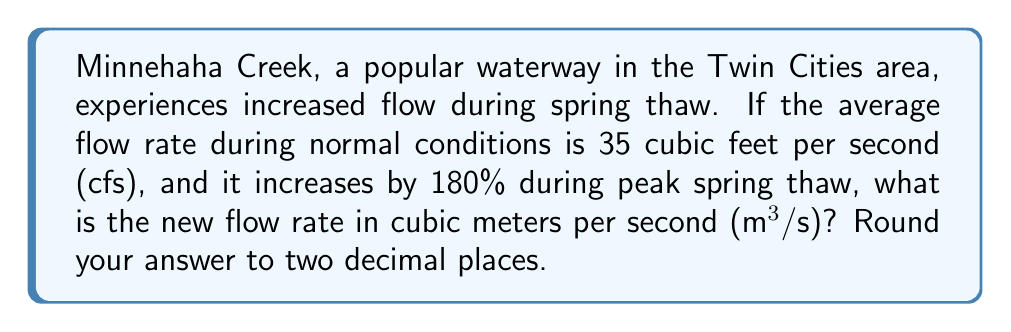Show me your answer to this math problem. Let's approach this problem step-by-step:

1. Identify the given information:
   - Normal flow rate: 35 cfs
   - Increase during spring thaw: 180%

2. Calculate the increase in flow rate:
   $$\text{Increase} = 35 \text{ cfs} \times 180\% = 35 \times 1.80 = 63 \text{ cfs}$$

3. Calculate the new flow rate in cfs:
   $$\text{New flow rate} = 35 \text{ cfs} + 63 \text{ cfs} = 98 \text{ cfs}$$

4. Convert from cubic feet per second to cubic meters per second:
   - 1 cubic foot = 0.0283168 cubic meters
   
   $$98 \text{ cfs} \times 0.0283168 \frac{\text{m}^3}{\text{ft}^3} = 2.77504704 \text{ m}^3/\text{s}$$

5. Round the result to two decimal places:
   $$2.77504704 \text{ m}^3/\text{s} \approx 2.78 \text{ m}^3/\text{s}$$
Answer: $2.78 \text{ m}^3/\text{s}$ 